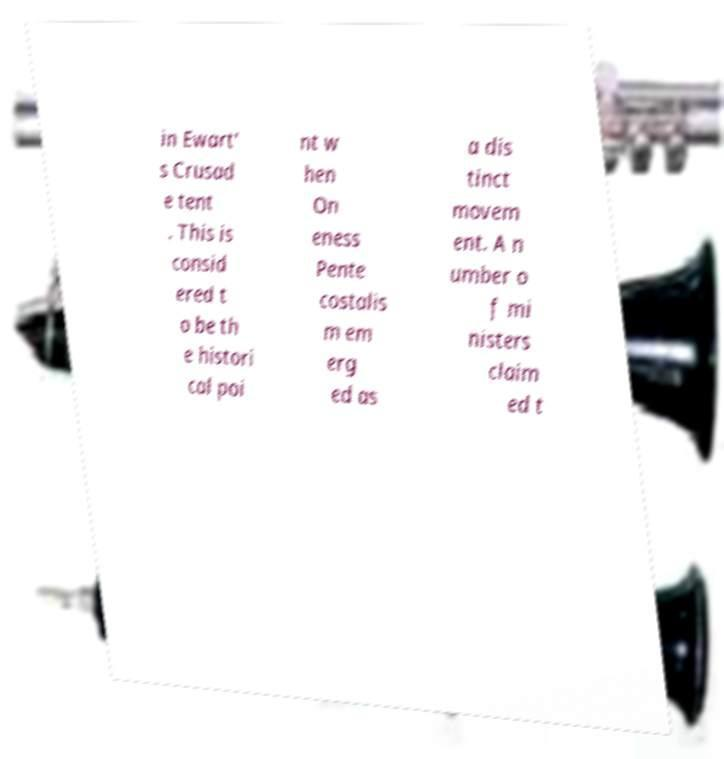Please read and relay the text visible in this image. What does it say? in Ewart' s Crusad e tent . This is consid ered t o be th e histori cal poi nt w hen On eness Pente costalis m em erg ed as a dis tinct movem ent. A n umber o f mi nisters claim ed t 